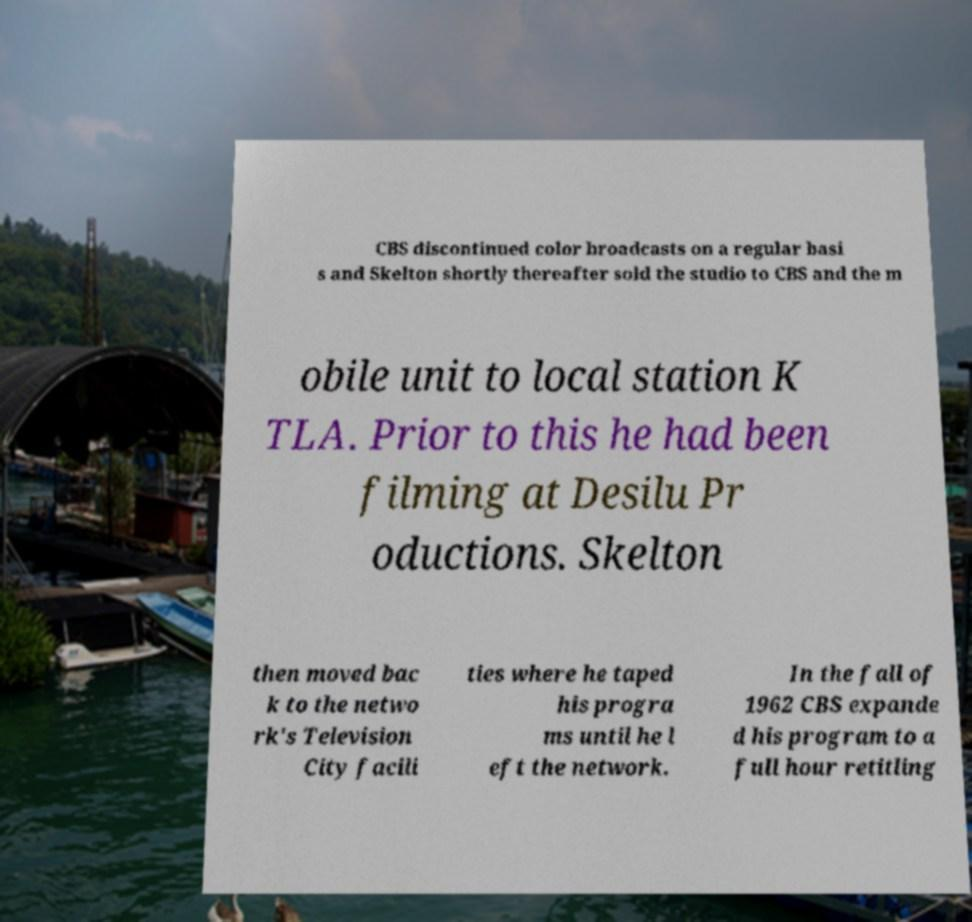Can you read and provide the text displayed in the image?This photo seems to have some interesting text. Can you extract and type it out for me? CBS discontinued color broadcasts on a regular basi s and Skelton shortly thereafter sold the studio to CBS and the m obile unit to local station K TLA. Prior to this he had been filming at Desilu Pr oductions. Skelton then moved bac k to the netwo rk's Television City facili ties where he taped his progra ms until he l eft the network. In the fall of 1962 CBS expande d his program to a full hour retitling 